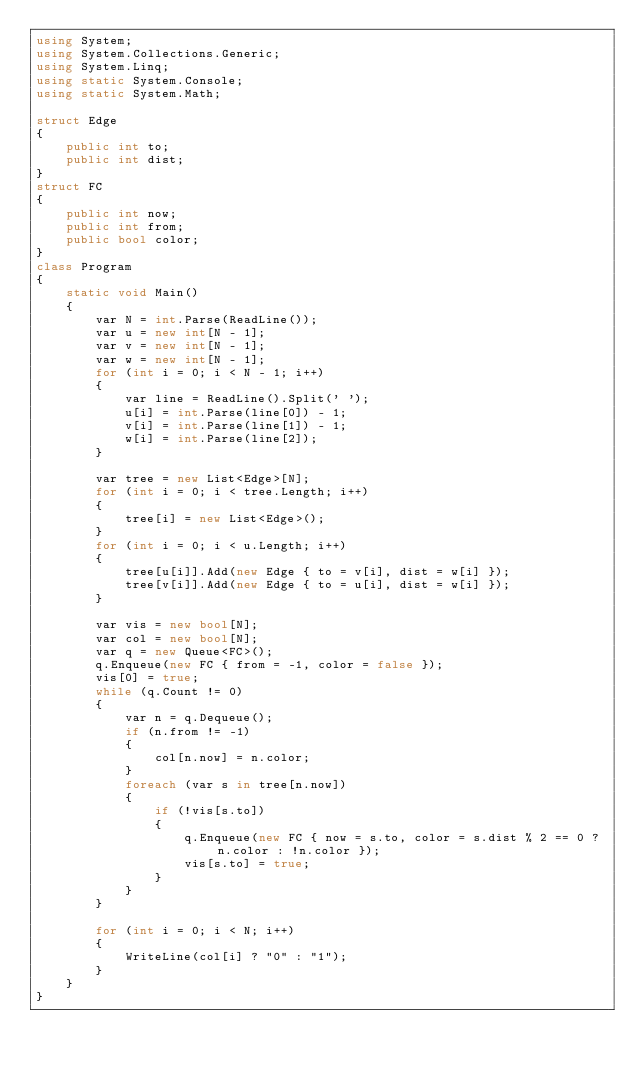Convert code to text. <code><loc_0><loc_0><loc_500><loc_500><_C#_>using System;
using System.Collections.Generic;
using System.Linq;
using static System.Console;
using static System.Math;

struct Edge
{
    public int to;
    public int dist;
}
struct FC
{
    public int now;
    public int from;
    public bool color;
}
class Program
{
    static void Main()
    {
        var N = int.Parse(ReadLine());
        var u = new int[N - 1];
        var v = new int[N - 1];
        var w = new int[N - 1];
        for (int i = 0; i < N - 1; i++)
        {
            var line = ReadLine().Split(' ');
            u[i] = int.Parse(line[0]) - 1;
            v[i] = int.Parse(line[1]) - 1;
            w[i] = int.Parse(line[2]);
        }

        var tree = new List<Edge>[N];
        for (int i = 0; i < tree.Length; i++)
        {
            tree[i] = new List<Edge>();
        }
        for (int i = 0; i < u.Length; i++)
        {
            tree[u[i]].Add(new Edge { to = v[i], dist = w[i] });
            tree[v[i]].Add(new Edge { to = u[i], dist = w[i] });
        }

        var vis = new bool[N];
        var col = new bool[N];
        var q = new Queue<FC>();
        q.Enqueue(new FC { from = -1, color = false });
        vis[0] = true;
        while (q.Count != 0)
        {
            var n = q.Dequeue();
            if (n.from != -1)
            {
                col[n.now] = n.color;
            }
            foreach (var s in tree[n.now])
            {
                if (!vis[s.to])
                {
                    q.Enqueue(new FC { now = s.to, color = s.dist % 2 == 0 ? n.color : !n.color });
                    vis[s.to] = true;
                }
            }
        }

        for (int i = 0; i < N; i++)
        {
            WriteLine(col[i] ? "0" : "1");
        }
    }
}
</code> 